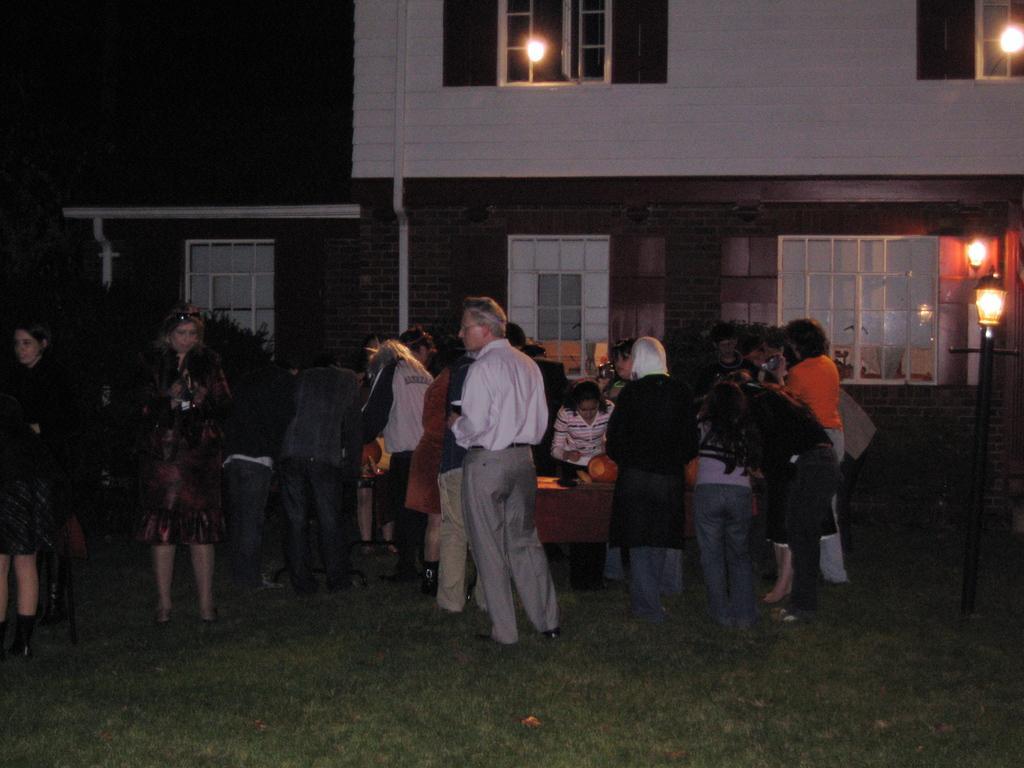How would you summarize this image in a sentence or two? The image is taken in the nighttime. In this image there are group of people who are standing around the table. In the background there is a building with the windows. On the right side there is a light. On the ground there is grass. 